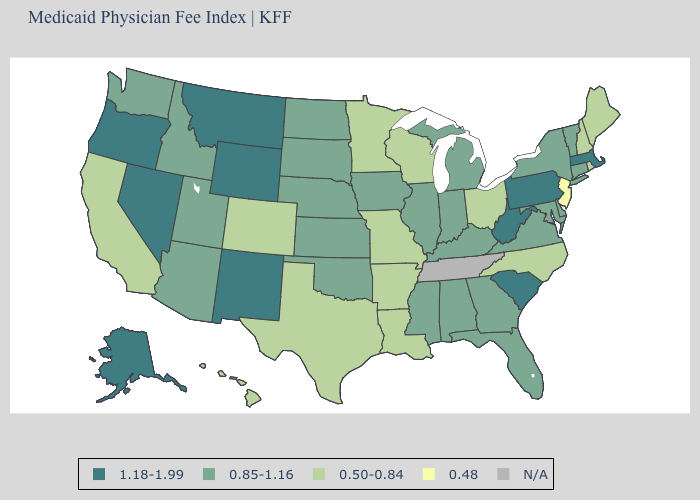What is the value of Illinois?
Write a very short answer. 0.85-1.16. What is the value of Hawaii?
Be succinct. 0.50-0.84. What is the value of Montana?
Be succinct. 1.18-1.99. Name the states that have a value in the range N/A?
Quick response, please. Tennessee. Does Montana have the highest value in the West?
Short answer required. Yes. What is the lowest value in the South?
Give a very brief answer. 0.50-0.84. Among the states that border Ohio , which have the lowest value?
Short answer required. Indiana, Kentucky, Michigan. How many symbols are there in the legend?
Be succinct. 5. Name the states that have a value in the range N/A?
Short answer required. Tennessee. What is the highest value in states that border Texas?
Short answer required. 1.18-1.99. What is the value of Oregon?
Answer briefly. 1.18-1.99. What is the lowest value in the USA?
Quick response, please. 0.48. Among the states that border Wyoming , which have the highest value?
Keep it brief. Montana. Does Arkansas have the lowest value in the South?
Short answer required. Yes. Name the states that have a value in the range 0.50-0.84?
Quick response, please. Arkansas, California, Colorado, Hawaii, Louisiana, Maine, Minnesota, Missouri, New Hampshire, North Carolina, Ohio, Rhode Island, Texas, Wisconsin. 